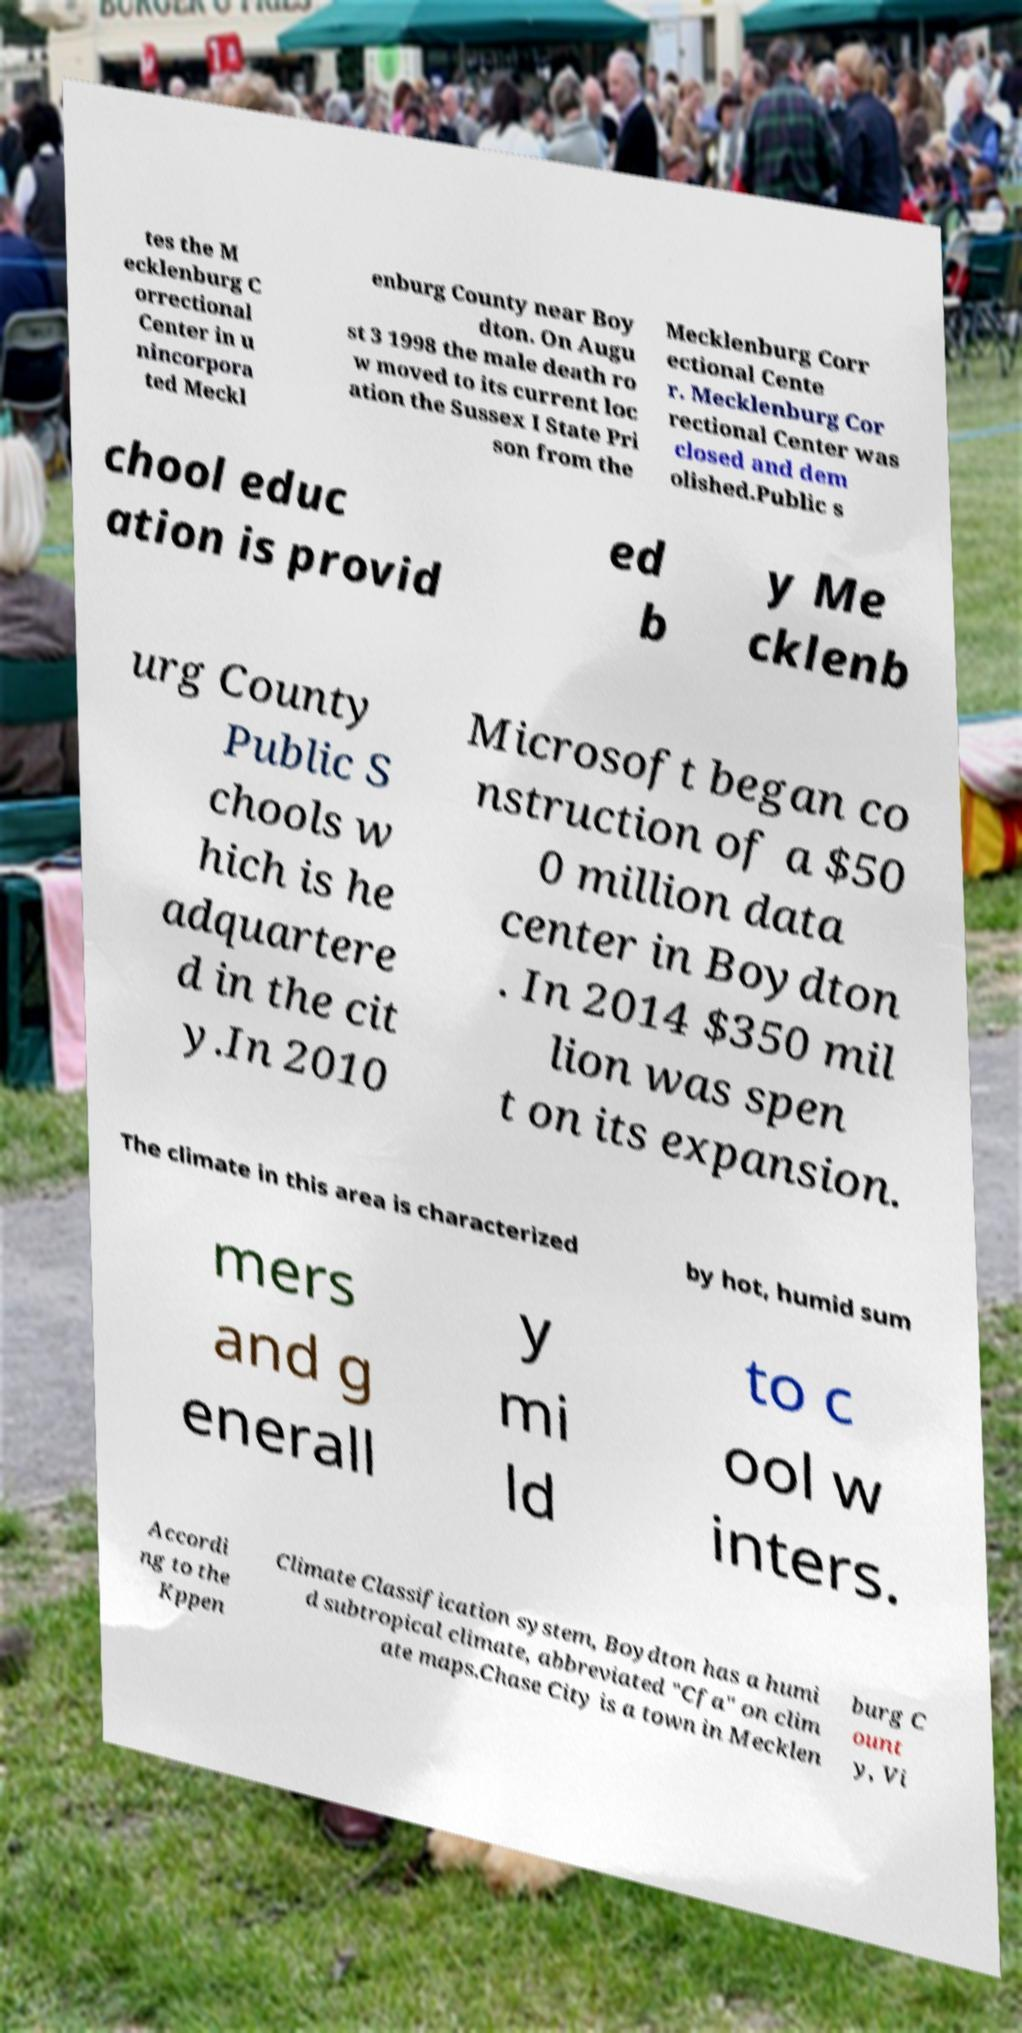There's text embedded in this image that I need extracted. Can you transcribe it verbatim? tes the M ecklenburg C orrectional Center in u nincorpora ted Meckl enburg County near Boy dton. On Augu st 3 1998 the male death ro w moved to its current loc ation the Sussex I State Pri son from the Mecklenburg Corr ectional Cente r. Mecklenburg Cor rectional Center was closed and dem olished.Public s chool educ ation is provid ed b y Me cklenb urg County Public S chools w hich is he adquartere d in the cit y.In 2010 Microsoft began co nstruction of a $50 0 million data center in Boydton . In 2014 $350 mil lion was spen t on its expansion. The climate in this area is characterized by hot, humid sum mers and g enerall y mi ld to c ool w inters. Accordi ng to the Kppen Climate Classification system, Boydton has a humi d subtropical climate, abbreviated "Cfa" on clim ate maps.Chase City is a town in Mecklen burg C ount y, Vi 